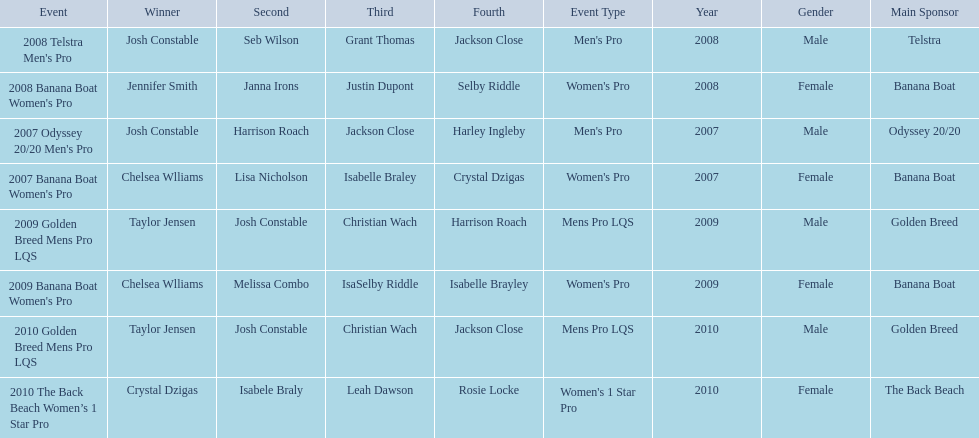How many times was josh constable the winner after 2007? 1. 